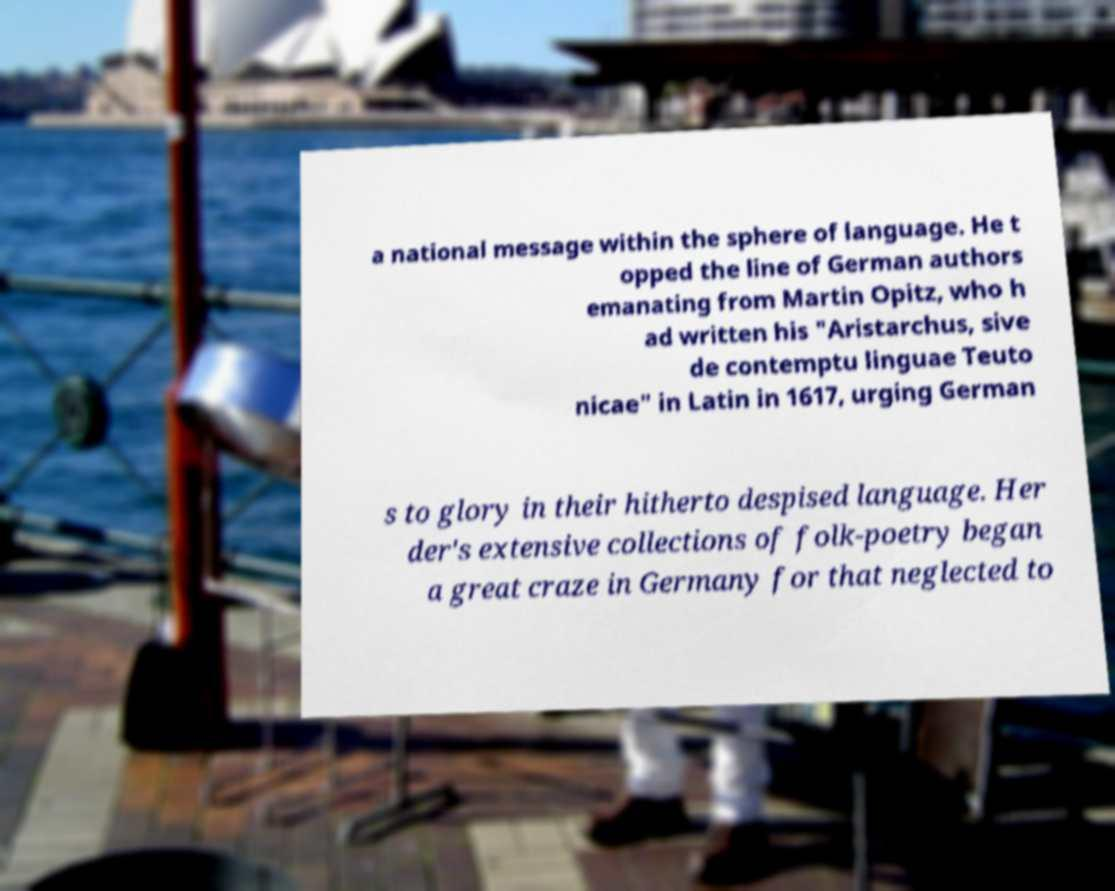What messages or text are displayed in this image? I need them in a readable, typed format. a national message within the sphere of language. He t opped the line of German authors emanating from Martin Opitz, who h ad written his "Aristarchus, sive de contemptu linguae Teuto nicae" in Latin in 1617, urging German s to glory in their hitherto despised language. Her der's extensive collections of folk-poetry began a great craze in Germany for that neglected to 